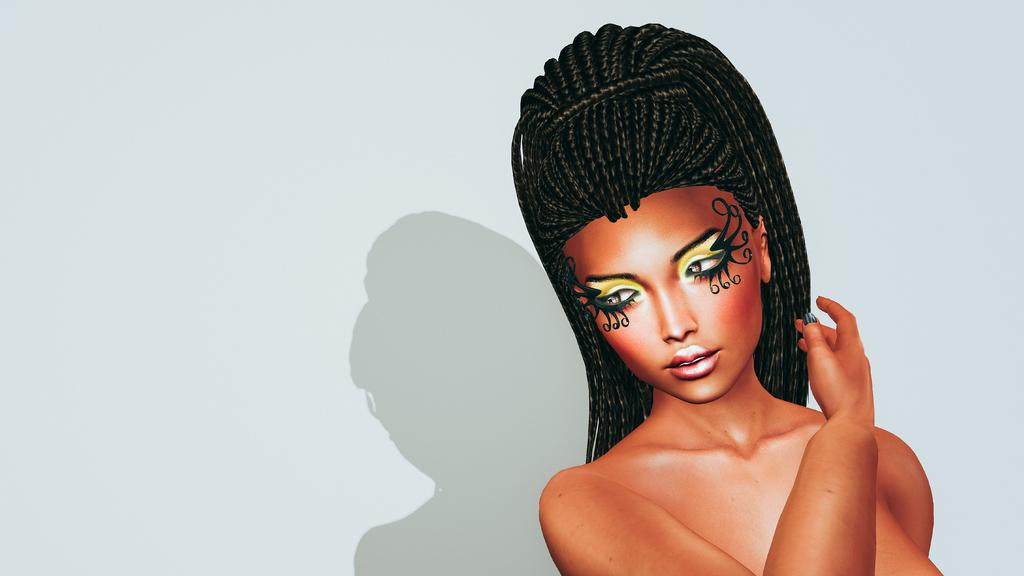What type of picture is featured in the image? The image contains an animated picture. What color is the background of the image? The background of the image is white. How many knots are tied in the image? There are no knots present in the image. What time of day is depicted in the image? The image does not depict a specific time of day, so it is not possible to determine the hour. 